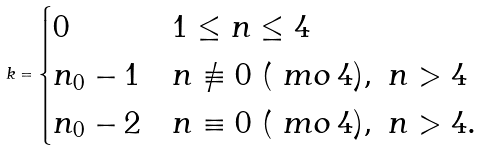Convert formula to latex. <formula><loc_0><loc_0><loc_500><loc_500>k = \begin{cases} 0 & 1 \leq n \leq 4 \\ n _ { 0 } - 1 & n \not \equiv 0 \ ( \ m o \, 4 ) , \ n > 4 \\ n _ { 0 } - 2 & n \equiv 0 \ ( \ m o \, 4 ) , \ n > 4 . \end{cases}</formula> 